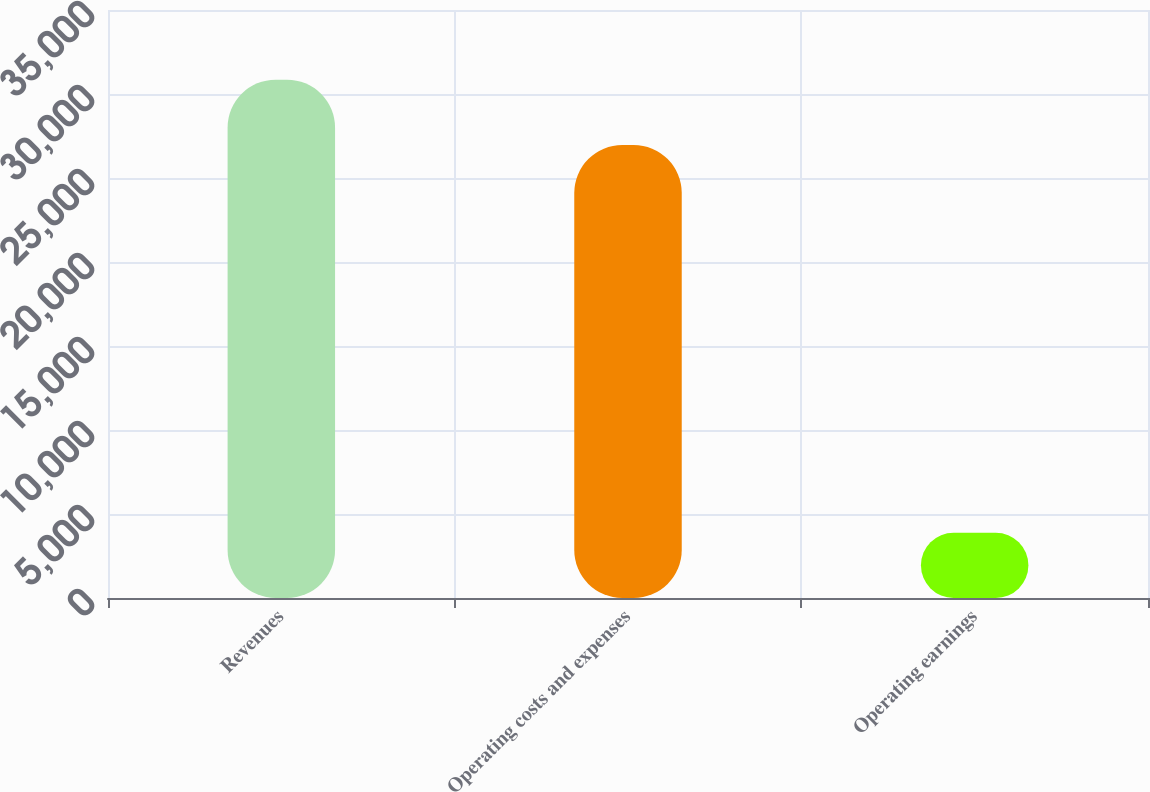Convert chart. <chart><loc_0><loc_0><loc_500><loc_500><bar_chart><fcel>Revenues<fcel>Operating costs and expenses<fcel>Operating earnings<nl><fcel>30852<fcel>26963<fcel>3889<nl></chart> 